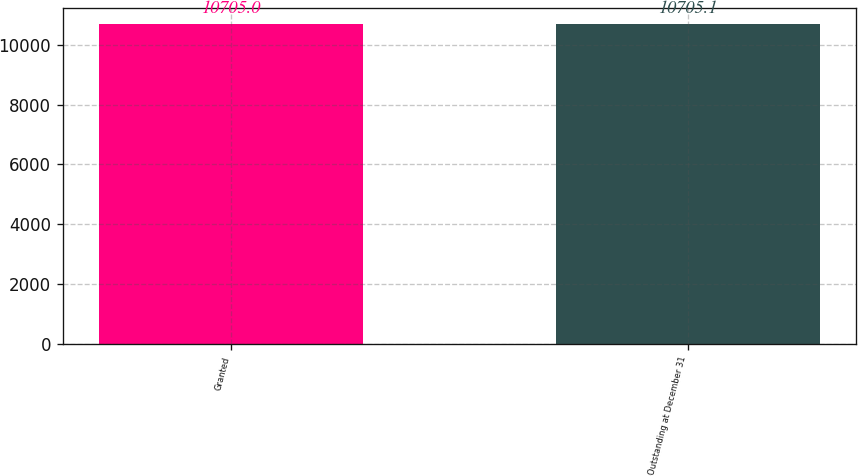Convert chart. <chart><loc_0><loc_0><loc_500><loc_500><bar_chart><fcel>Granted<fcel>Outstanding at December 31<nl><fcel>10705<fcel>10705.1<nl></chart> 